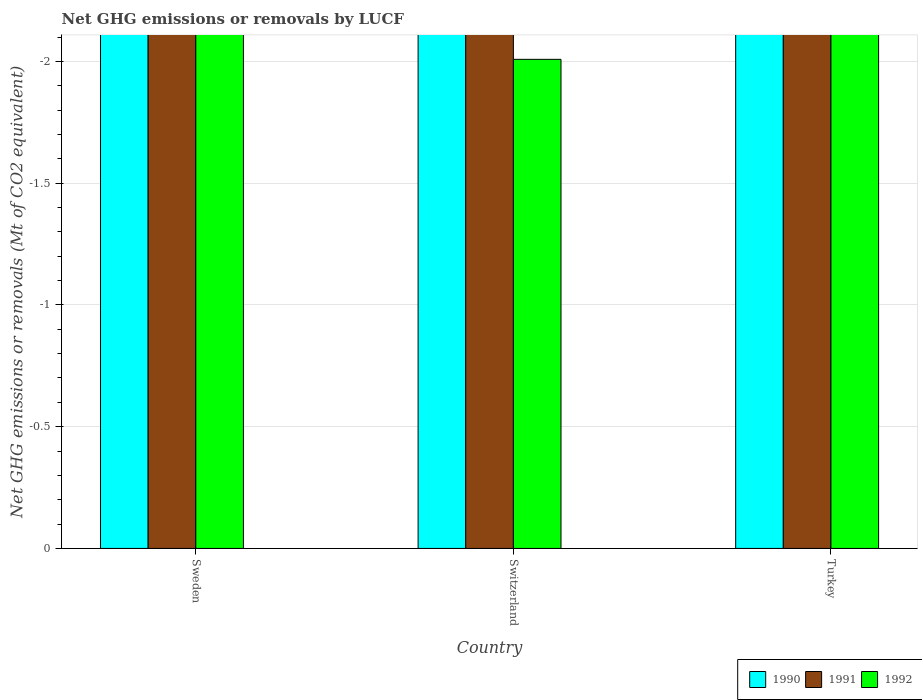How many different coloured bars are there?
Make the answer very short. 0. Are the number of bars per tick equal to the number of legend labels?
Provide a short and direct response. No. Are the number of bars on each tick of the X-axis equal?
Give a very brief answer. Yes. How many bars are there on the 2nd tick from the left?
Keep it short and to the point. 0. What is the label of the 3rd group of bars from the left?
Keep it short and to the point. Turkey. What is the net GHG emissions or removals by LUCF in 1991 in Sweden?
Provide a succinct answer. 0. What is the difference between the net GHG emissions or removals by LUCF in 1991 in Turkey and the net GHG emissions or removals by LUCF in 1992 in Sweden?
Your answer should be compact. 0. In how many countries, is the net GHG emissions or removals by LUCF in 1991 greater than -0.5 Mt?
Give a very brief answer. 0. Is it the case that in every country, the sum of the net GHG emissions or removals by LUCF in 1990 and net GHG emissions or removals by LUCF in 1991 is greater than the net GHG emissions or removals by LUCF in 1992?
Ensure brevity in your answer.  No. Are all the bars in the graph horizontal?
Offer a terse response. No. Are the values on the major ticks of Y-axis written in scientific E-notation?
Give a very brief answer. No. Does the graph contain any zero values?
Keep it short and to the point. Yes. Does the graph contain grids?
Offer a terse response. Yes. What is the title of the graph?
Your response must be concise. Net GHG emissions or removals by LUCF. What is the label or title of the X-axis?
Offer a terse response. Country. What is the label or title of the Y-axis?
Your answer should be very brief. Net GHG emissions or removals (Mt of CO2 equivalent). What is the Net GHG emissions or removals (Mt of CO2 equivalent) of 1991 in Sweden?
Provide a short and direct response. 0. What is the Net GHG emissions or removals (Mt of CO2 equivalent) in 1990 in Switzerland?
Your answer should be very brief. 0. What is the Net GHG emissions or removals (Mt of CO2 equivalent) in 1992 in Turkey?
Keep it short and to the point. 0. What is the total Net GHG emissions or removals (Mt of CO2 equivalent) in 1990 in the graph?
Provide a short and direct response. 0. What is the total Net GHG emissions or removals (Mt of CO2 equivalent) in 1991 in the graph?
Your answer should be very brief. 0. What is the total Net GHG emissions or removals (Mt of CO2 equivalent) of 1992 in the graph?
Ensure brevity in your answer.  0. What is the average Net GHG emissions or removals (Mt of CO2 equivalent) in 1991 per country?
Offer a terse response. 0. 